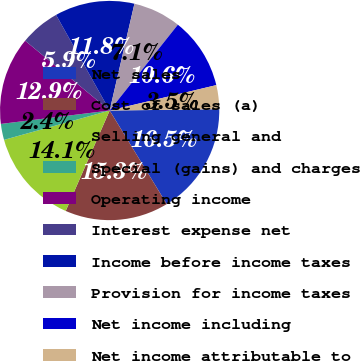Convert chart to OTSL. <chart><loc_0><loc_0><loc_500><loc_500><pie_chart><fcel>Net sales<fcel>Cost of sales (a)<fcel>Selling general and<fcel>Special (gains) and charges<fcel>Operating income<fcel>Interest expense net<fcel>Income before income taxes<fcel>Provision for income taxes<fcel>Net income including<fcel>Net income attributable to<nl><fcel>16.47%<fcel>15.29%<fcel>14.12%<fcel>2.36%<fcel>12.94%<fcel>5.88%<fcel>11.76%<fcel>7.06%<fcel>10.59%<fcel>3.53%<nl></chart> 